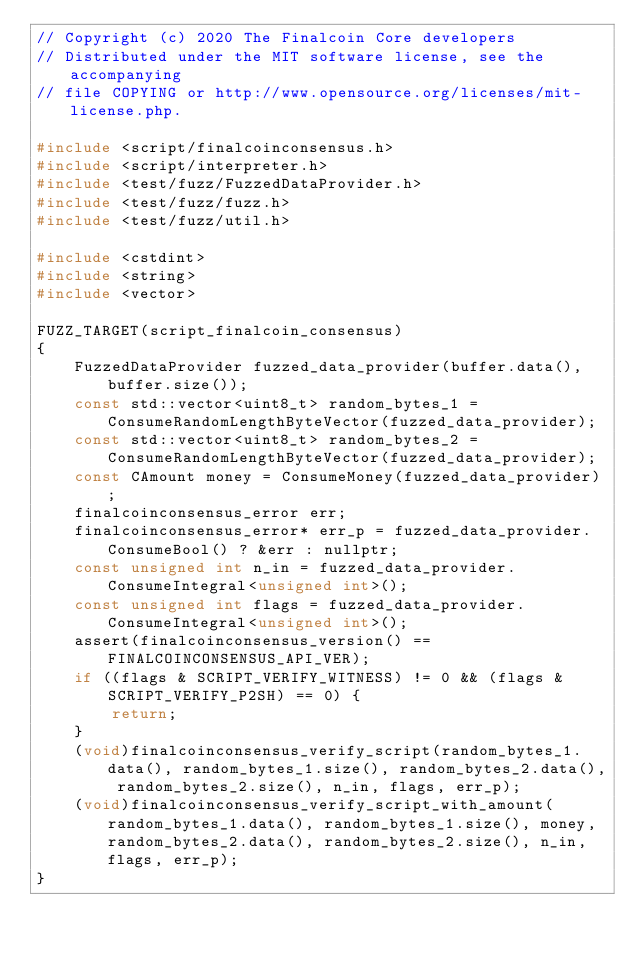Convert code to text. <code><loc_0><loc_0><loc_500><loc_500><_C++_>// Copyright (c) 2020 The Finalcoin Core developers
// Distributed under the MIT software license, see the accompanying
// file COPYING or http://www.opensource.org/licenses/mit-license.php.

#include <script/finalcoinconsensus.h>
#include <script/interpreter.h>
#include <test/fuzz/FuzzedDataProvider.h>
#include <test/fuzz/fuzz.h>
#include <test/fuzz/util.h>

#include <cstdint>
#include <string>
#include <vector>

FUZZ_TARGET(script_finalcoin_consensus)
{
    FuzzedDataProvider fuzzed_data_provider(buffer.data(), buffer.size());
    const std::vector<uint8_t> random_bytes_1 = ConsumeRandomLengthByteVector(fuzzed_data_provider);
    const std::vector<uint8_t> random_bytes_2 = ConsumeRandomLengthByteVector(fuzzed_data_provider);
    const CAmount money = ConsumeMoney(fuzzed_data_provider);
    finalcoinconsensus_error err;
    finalcoinconsensus_error* err_p = fuzzed_data_provider.ConsumeBool() ? &err : nullptr;
    const unsigned int n_in = fuzzed_data_provider.ConsumeIntegral<unsigned int>();
    const unsigned int flags = fuzzed_data_provider.ConsumeIntegral<unsigned int>();
    assert(finalcoinconsensus_version() == FINALCOINCONSENSUS_API_VER);
    if ((flags & SCRIPT_VERIFY_WITNESS) != 0 && (flags & SCRIPT_VERIFY_P2SH) == 0) {
        return;
    }
    (void)finalcoinconsensus_verify_script(random_bytes_1.data(), random_bytes_1.size(), random_bytes_2.data(), random_bytes_2.size(), n_in, flags, err_p);
    (void)finalcoinconsensus_verify_script_with_amount(random_bytes_1.data(), random_bytes_1.size(), money, random_bytes_2.data(), random_bytes_2.size(), n_in, flags, err_p);
}
</code> 